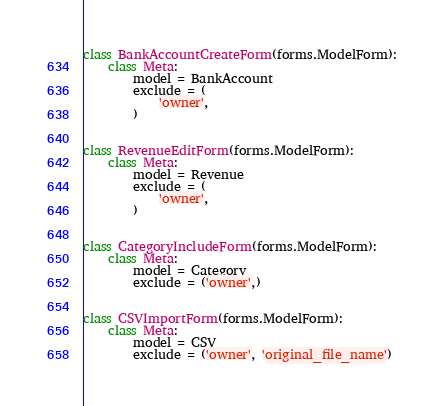Convert code to text. <code><loc_0><loc_0><loc_500><loc_500><_Python_>

class BankAccountCreateForm(forms.ModelForm):
    class Meta:
        model = BankAccount
        exclude = (
            'owner',
        )


class RevenueEditForm(forms.ModelForm):
    class Meta:
        model = Revenue
        exclude = (
            'owner',
        )


class CategoryIncludeForm(forms.ModelForm):
    class Meta:
        model = Category
        exclude = ('owner',)


class CSVImportForm(forms.ModelForm):
    class Meta:
        model = CSV
        exclude = ('owner', 'original_file_name')
</code> 